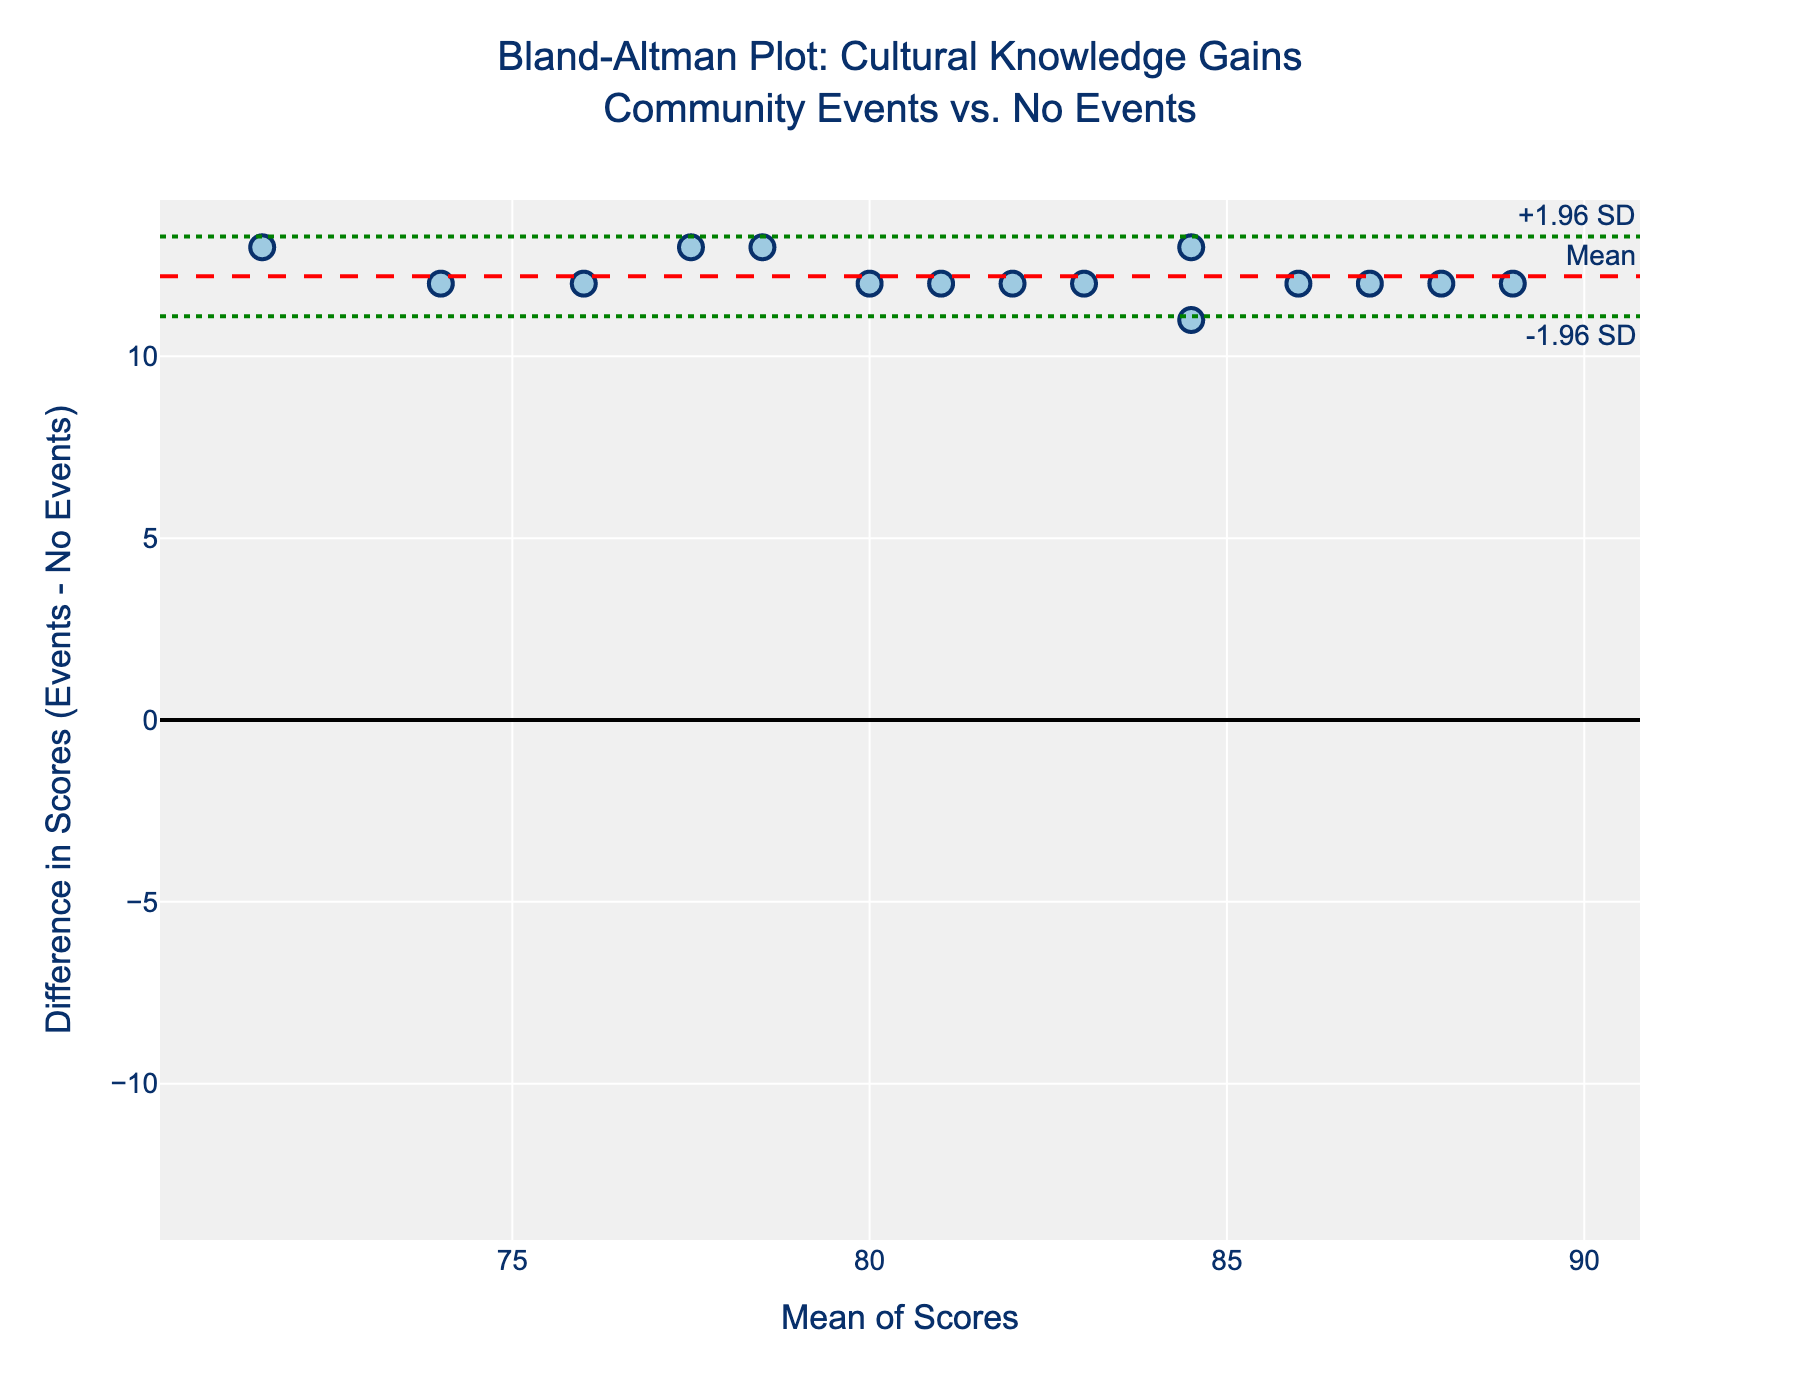What is the title of the plot? The title is located at the top of the plot and provides a summary of the data being represented.
Answer: Bland-Altman Plot: Cultural Knowledge Gains<br>Community Events vs. No Events What do the green dotted lines represent? The green dotted lines indicate ±1.96 standard deviations from the mean difference, representing the limits of agreement.
Answer: ±1.96 SD What is the mean difference in the cultural knowledge scores between community event participants and non-participants? The red dashed line on the y-axis represents the mean difference.
Answer: Approximately 12 How many students have their names displayed in the hover text? Each data point represents a student, and their names appear when hovered over.
Answer: 15 Which student has the highest mean score between the community event and non-event knowledge scores? Hovering over the scatter points shows the names and mean scores. The highest mean score decides the student.
Answer: Hasmik Vardanyan What is the range of the x-axis (mean scores)? The x-axis range can be determined by observing the min and max values marked on the axis.
Answer: Approximately [70.5, 94.5] Does anyone have a negative score difference between attending and not attending community events? Check if any data points are below the zero line on the y-axis.
Answer: No What is the overall trend shown by the points on the plot? Observing the scatter of points relative to the mean and limits of agreement can reveal the trend.
Answer: Positive differences, indicating gains from community events Who are the three students with the smallest positive difference in scores? Identify the three points closest above the zero line on the y-axis and refer to their hover text.
Answer: Tigran Petrosyan, Armen Grigoryan, Vahagn Manukyan What does the plot suggest about the effectiveness of Armenian community events on cultural knowledge? The majority of points are above the zero line, indicating a consistent positive difference in scores for event participants.
Answer: Community events improve cultural knowledge 